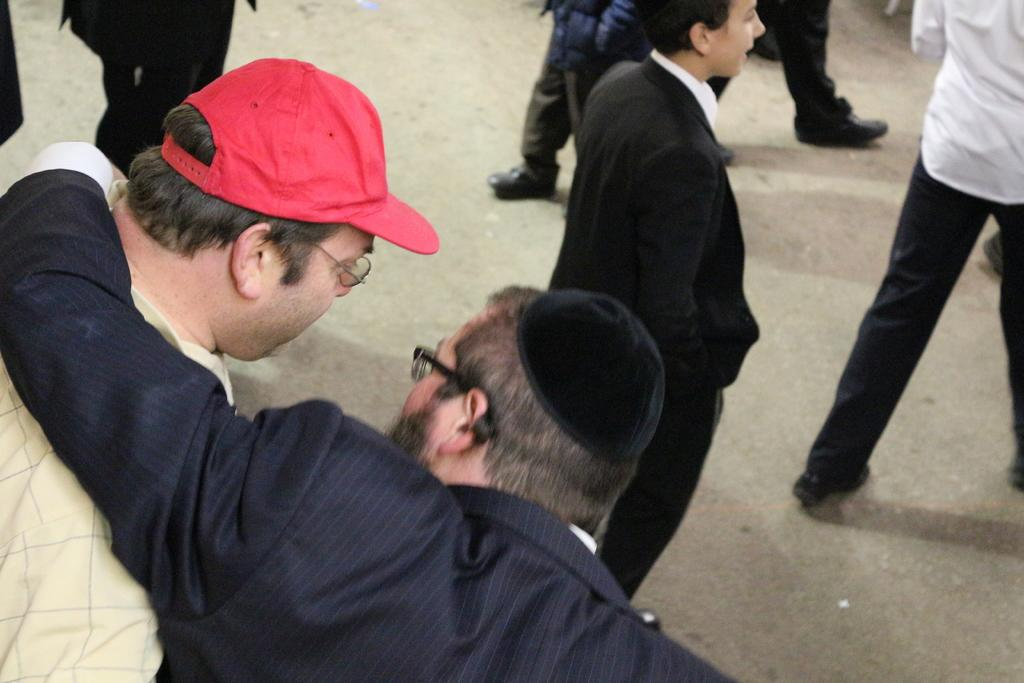What is the person in the image wearing? The person in the image is wearing a black suit. What is the person in the black suit doing with their hand? The person in the black suit has their hand placed on another person beside them. How many other persons are in front of the person in the black suit? There are other persons in front of the person in the black suit. What type of crime is being committed by the monkey in the image? There is no monkey present in the image, and therefore no crime can be committed by a monkey. 